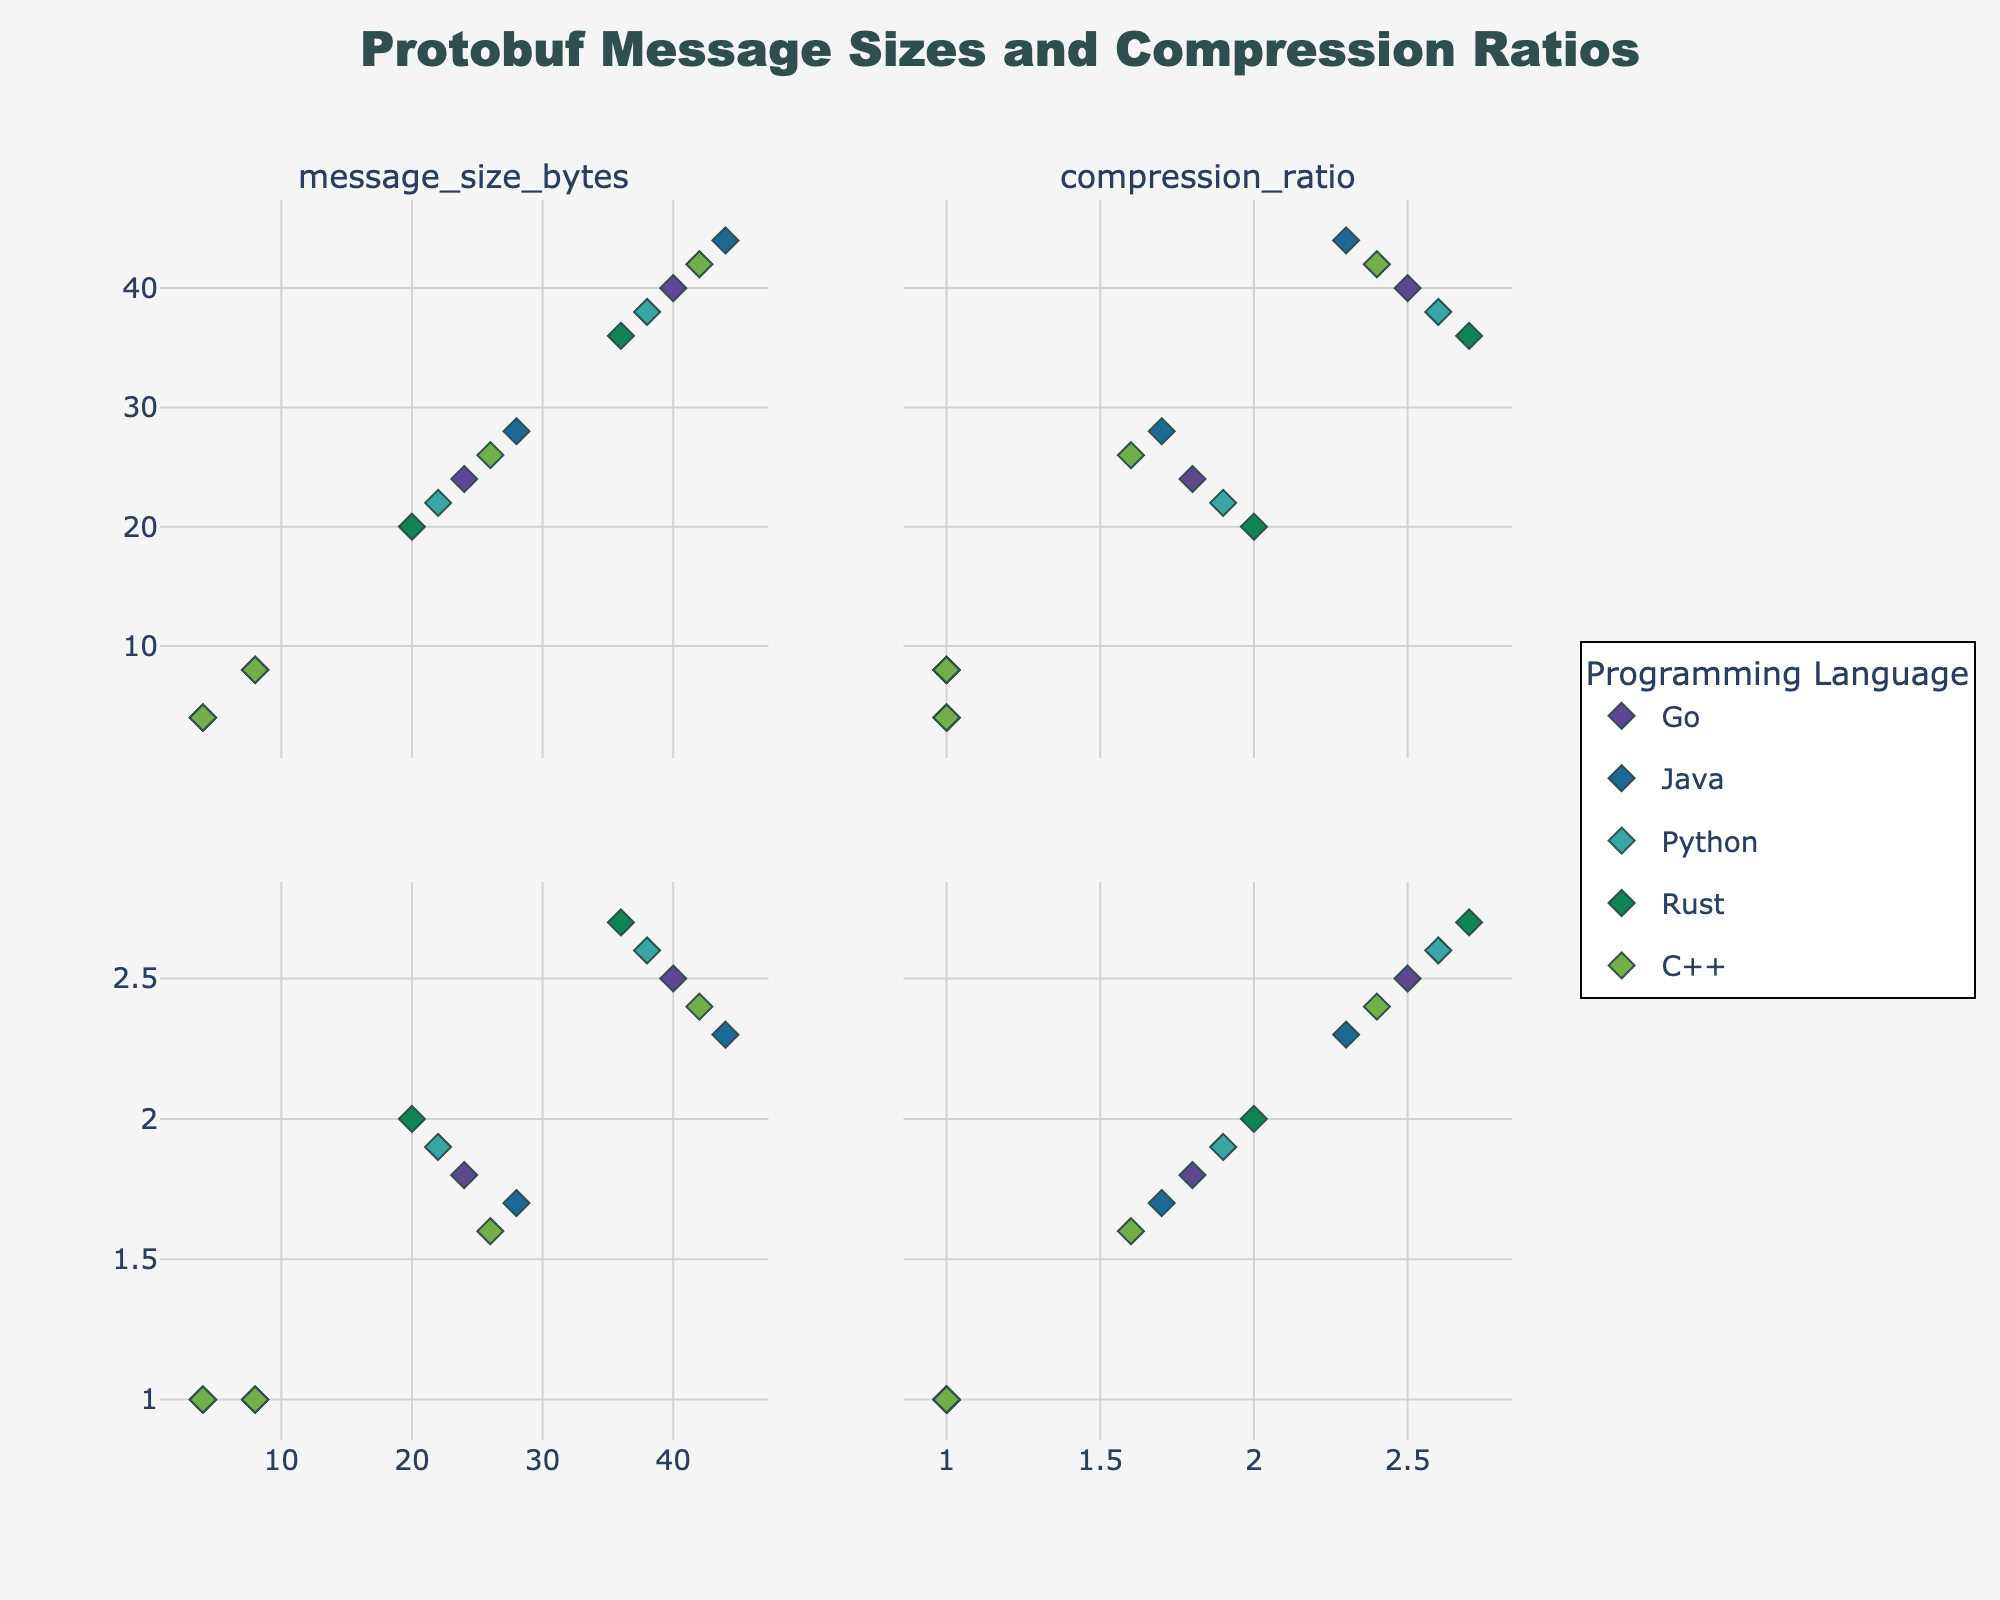Which river shows the highest Water Quality Index in 2020? To determine this, look at the last data point for each river’s subplot in the year 2020. The Thames river has the highest Water Quality Index with a value of 82.
Answer: Thames What is the average Water Quality Index improvement for the Rhine from 2010 to 2020? First, identify the Water Quality Index for the Rhine in 2010 (70) and 2020 (81). Compute the difference between these values (81 - 70 = 11). Divide by the number of years (2020 - 2010 = 10) and compute the average improvement: 11/10 = 1.1 per year.
Answer: 1.1 Between the Yangtze and Mississippi rivers, which one had a higher Water Quality Index in 2015? Compare the 2015 points for both rivers. Yangtze has a Water Quality Index of 64, whereas the Mississippi has 68. Therefore, the Mississippi river had a higher Water Quality Index in 2015.
Answer: Mississippi How does investment in conservation measures correlate with the Water Quality Index for the Danube river? In the Danube subplot, notice the upward trend line between Investment (x-axis) and Water Quality Index (y-axis). As Investment increases from 18 to 38 million USD, the Water Quality Index rises from 65 to 78, indicating a positive correlation.
Answer: Positive correlation What is the change in Water Quality Index for the Thames river from 2010 to 2020? Identify the indices in both years: Thames had a Water Quality Index of 71 in 2010 and 82 in 2020. Compute the difference: 82 - 71 = 11.
Answer: 11 Which river had the minimum starting Water Quality Index in 2010? Examine the 2010 data points for all rivers. The Yangtze river has the minimum starting Water Quality Index with a value of 58.
Answer: Yangtze Is the investment made in the Yangtze river in 2020 higher than that in the Rhine river in 2020? Compare the 2020 investment values: Yangtze shows 42 million USD, whereas the Rhine shows 40 million USD. Hence, the investment for the Yangtze river in 2020 is higher.
Answer: Yes What is the relationship between investment and Water Quality Index for all rivers combined? By observing the general trends across all subplots, investments in conservation measures consistently appear to correlate with improvements in Water Quality Index, suggesting that higher investments often lead to better water quality.
Answer: Positive relationship 